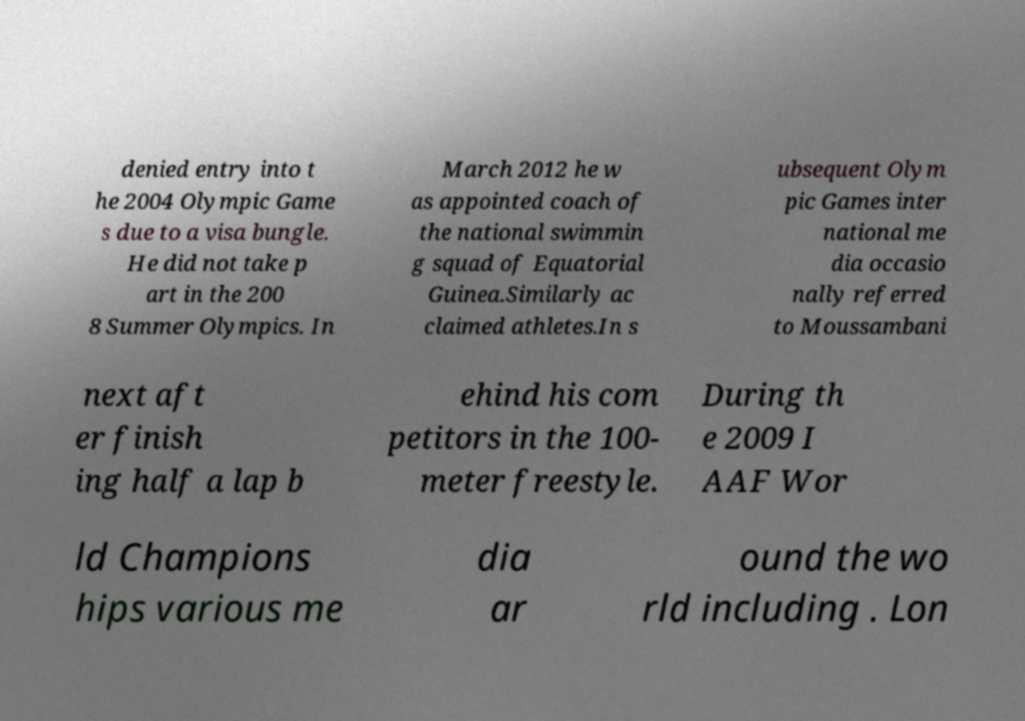Please identify and transcribe the text found in this image. denied entry into t he 2004 Olympic Game s due to a visa bungle. He did not take p art in the 200 8 Summer Olympics. In March 2012 he w as appointed coach of the national swimmin g squad of Equatorial Guinea.Similarly ac claimed athletes.In s ubsequent Olym pic Games inter national me dia occasio nally referred to Moussambani next aft er finish ing half a lap b ehind his com petitors in the 100- meter freestyle. During th e 2009 I AAF Wor ld Champions hips various me dia ar ound the wo rld including . Lon 